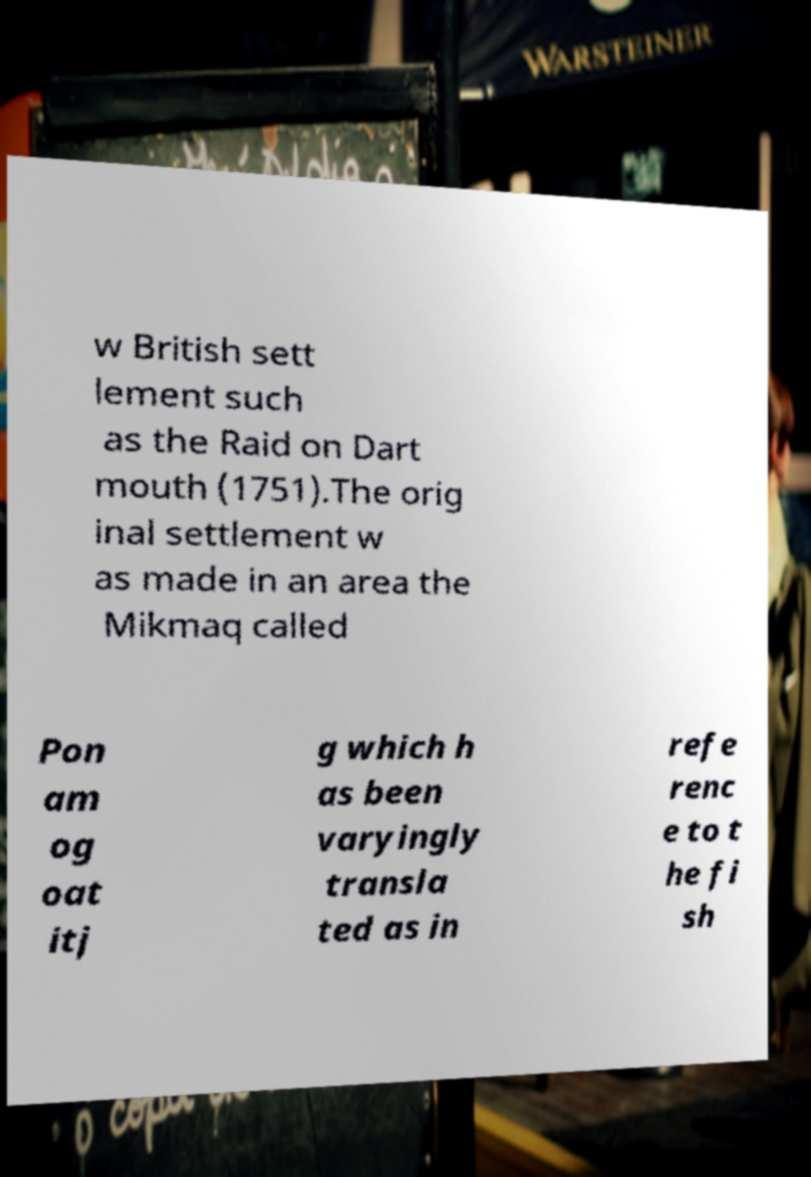I need the written content from this picture converted into text. Can you do that? w British sett lement such as the Raid on Dart mouth (1751).The orig inal settlement w as made in an area the Mikmaq called Pon am og oat itj g which h as been varyingly transla ted as in refe renc e to t he fi sh 